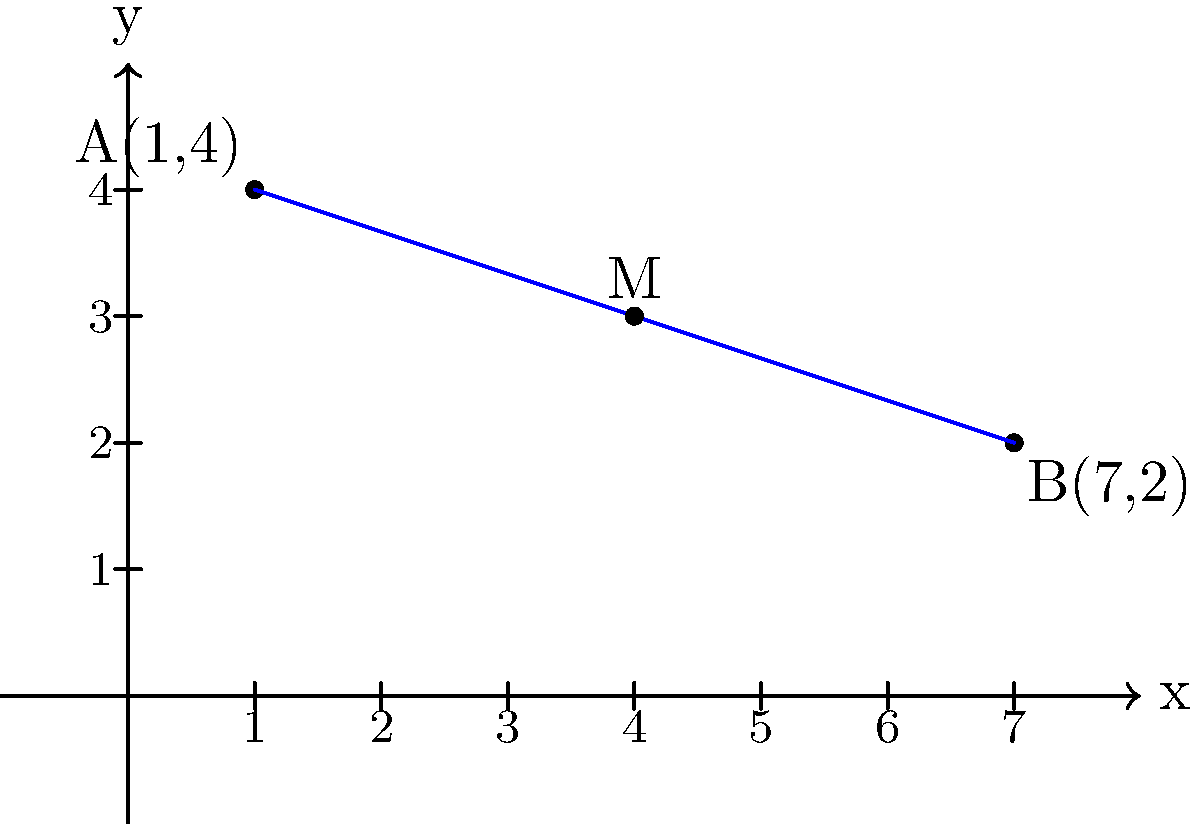As part of your interfaith outreach efforts, you are planning an event at the midpoint between two faith-based community centers. The coordinates of the centers are A(1,4) and B(7,2) on a city map grid. Calculate the coordinates of the midpoint M where the event will be held. To find the midpoint M between two points A(x₁,y₁) and B(x₂,y₂), we use the midpoint formula:

$$ M = (\frac{x_1 + x_2}{2}, \frac{y_1 + y_2}{2}) $$

Given:
- Point A: (1,4)
- Point B: (7,2)

Step 1: Calculate the x-coordinate of the midpoint:
$$ x_M = \frac{x_1 + x_2}{2} = \frac{1 + 7}{2} = \frac{8}{2} = 4 $$

Step 2: Calculate the y-coordinate of the midpoint:
$$ y_M = \frac{y_1 + y_2}{2} = \frac{4 + 2}{2} = \frac{6}{2} = 3 $$

Step 3: Combine the x and y coordinates to get the midpoint M:
$$ M = (4, 3) $$

Therefore, the coordinates of the midpoint M, where the interfaith event will be held, are (4,3).
Answer: (4,3) 